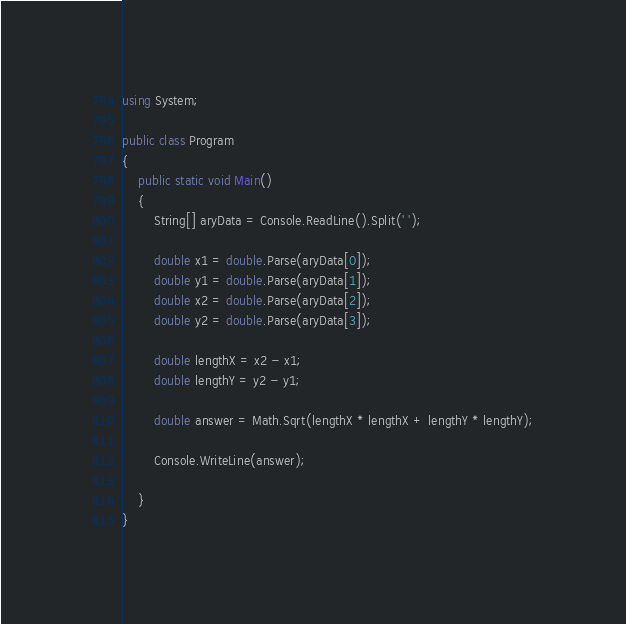<code> <loc_0><loc_0><loc_500><loc_500><_C#_>using System;

public class Program
{
    public static void Main()
    {
        String[] aryData = Console.ReadLine().Split(' ');

        double x1 = double.Parse(aryData[0]);
        double y1 = double.Parse(aryData[1]);
        double x2 = double.Parse(aryData[2]);
        double y2 = double.Parse(aryData[3]);

        double lengthX = x2 - x1;
        double lengthY = y2 - y1;

        double answer = Math.Sqrt(lengthX * lengthX + lengthY * lengthY);

        Console.WriteLine(answer);

    }
}</code> 